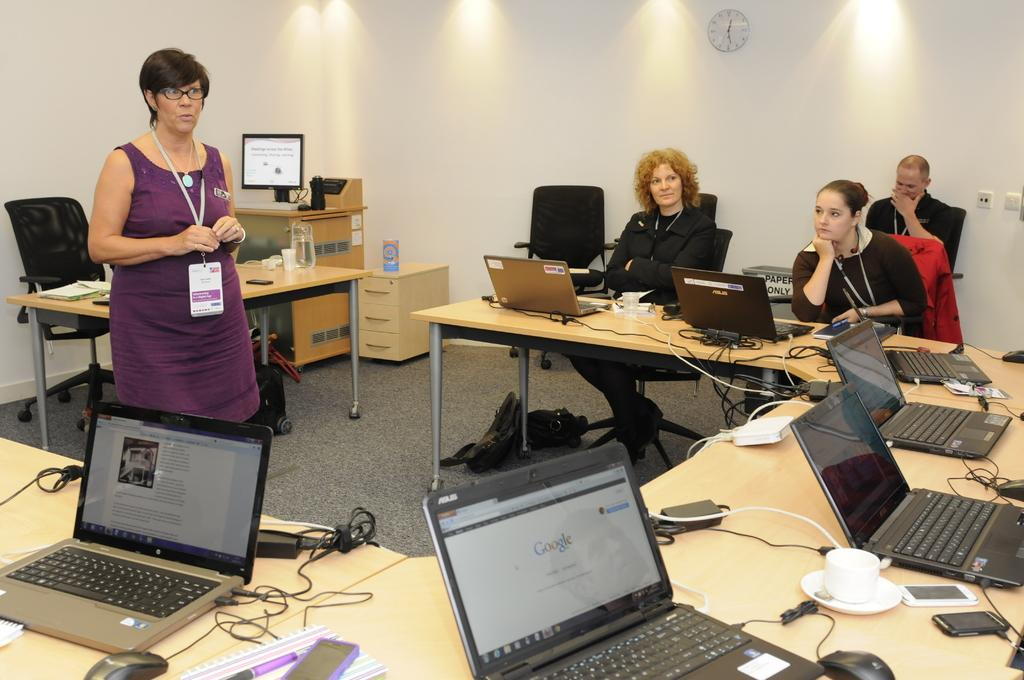<image>
Write a terse but informative summary of the picture. A woman wearing a lanyard speaks to people sitting at tables with laptops in front of them, one of the screens showing the Google logo. 